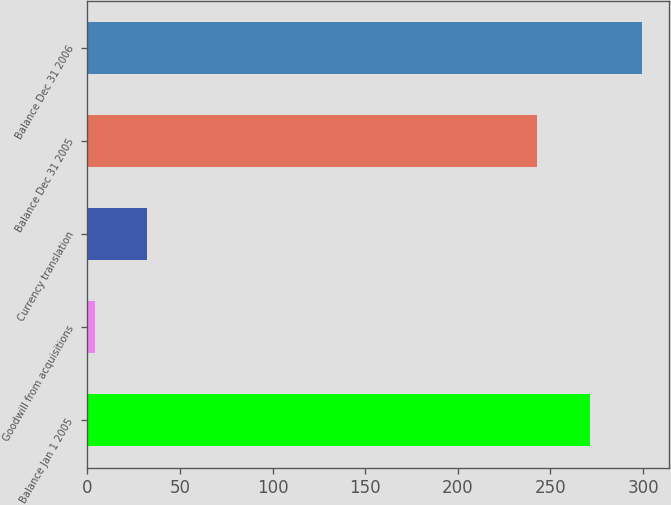Convert chart. <chart><loc_0><loc_0><loc_500><loc_500><bar_chart><fcel>Balance Jan 1 2005<fcel>Goodwill from acquisitions<fcel>Currency translation<fcel>Balance Dec 31 2005<fcel>Balance Dec 31 2006<nl><fcel>271.1<fcel>4<fcel>32.1<fcel>243<fcel>299.2<nl></chart> 